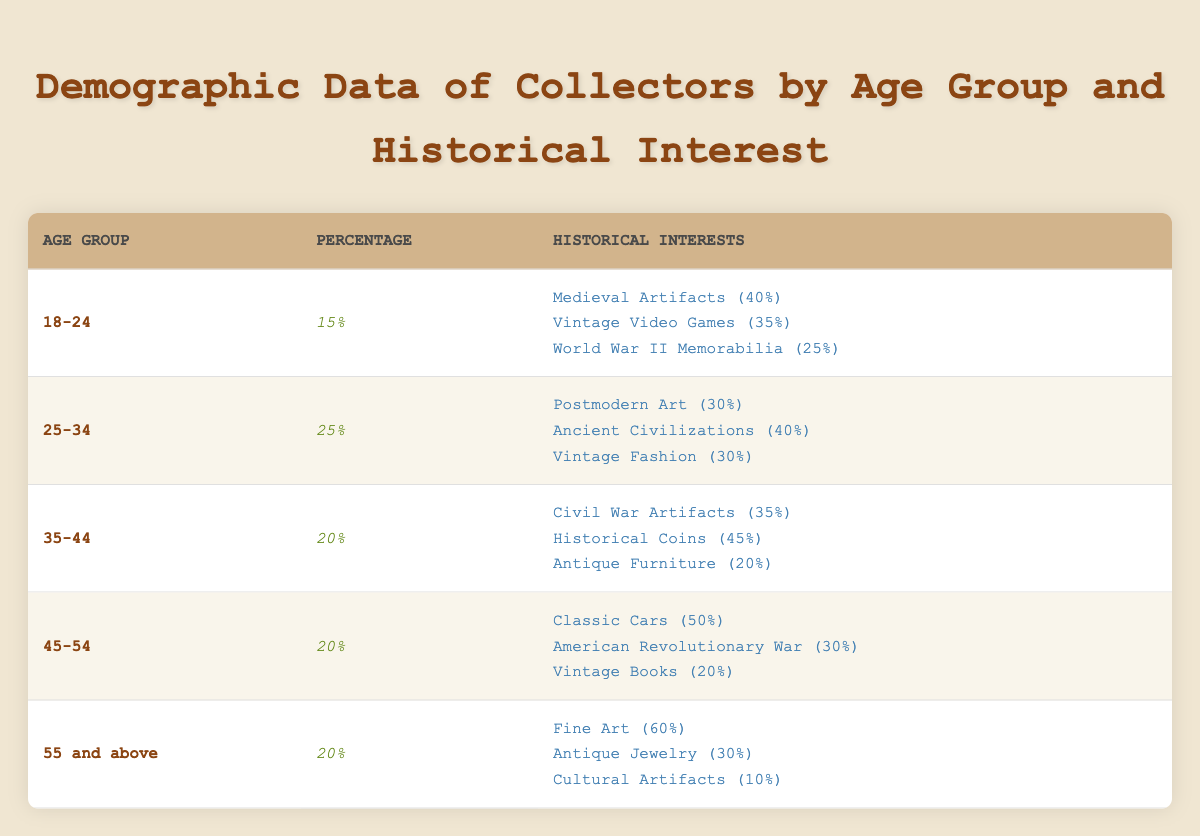What percentage of collectors are aged 25-34? From the table, we can see that the age group 25-34 has a percentage of 25%.
Answer: 25% Which historical interest has the highest percentage among collectors aged 55 and above? In the age group of 55 and above, the historical interest with the highest percentage is Fine Art, with 60%.
Answer: Fine Art (60%) Is there a specific historical interest that's equally popular among collectors aged 25-34? Yes, both Ancient Civilizations and Vintage Fashion have a popularity of 30%, making them equally popular in that age group.
Answer: Yes What is the combined percentage for collectors interested in Antique Jewelry and Cultural Artifacts in the 55 and above age group? The percentage for Antique Jewelry is 30% and for Cultural Artifacts is 10%. The combined percentage is 30% + 10% = 40%.
Answer: 40% Which age group has the lowest representation in terms of percentage? The age group 18-24 has the lowest representation with a percentage of 15%, compared to others which have higher percentages.
Answer: 18-24 (15%) What is the average percentage of all interested historical topics for the age group 35-44? The historical interests for the age group 35-44 are Civil War Artifacts (35%), Historical Coins (45%), and Antique Furniture (20%). The sum is 35 + 45 + 20 = 100; now divide by 3 for the average: 100 / 3 = 33.33%.
Answer: 33.33% True or False: Collectors aged 45-54 have a higher percentage interest in Classic Cars than those aged 35-44 have in Historical Coins. The percentage for Classic Cars among the 45-54 age group is 50%, whereas the percentage for Historical Coins in the 35-44 age group is 45%. Since 50% is higher than 45%, the statement is true.
Answer: True Which historical interest shows the least engagement among collectors in the 18-24 age group? In the 18-24 age group, World War II Memorabilia at 25% shows the least engagement compared to the other interests, Medieval Artifacts (40%) and Vintage Video Games (35%).
Answer: World War II Memorabilia (25%) What percentage of collectors aged 45-54 are interested in Vintage Books? According to the table, the interest in Vintage Books among the 45-54 age group is 20%.
Answer: 20% 